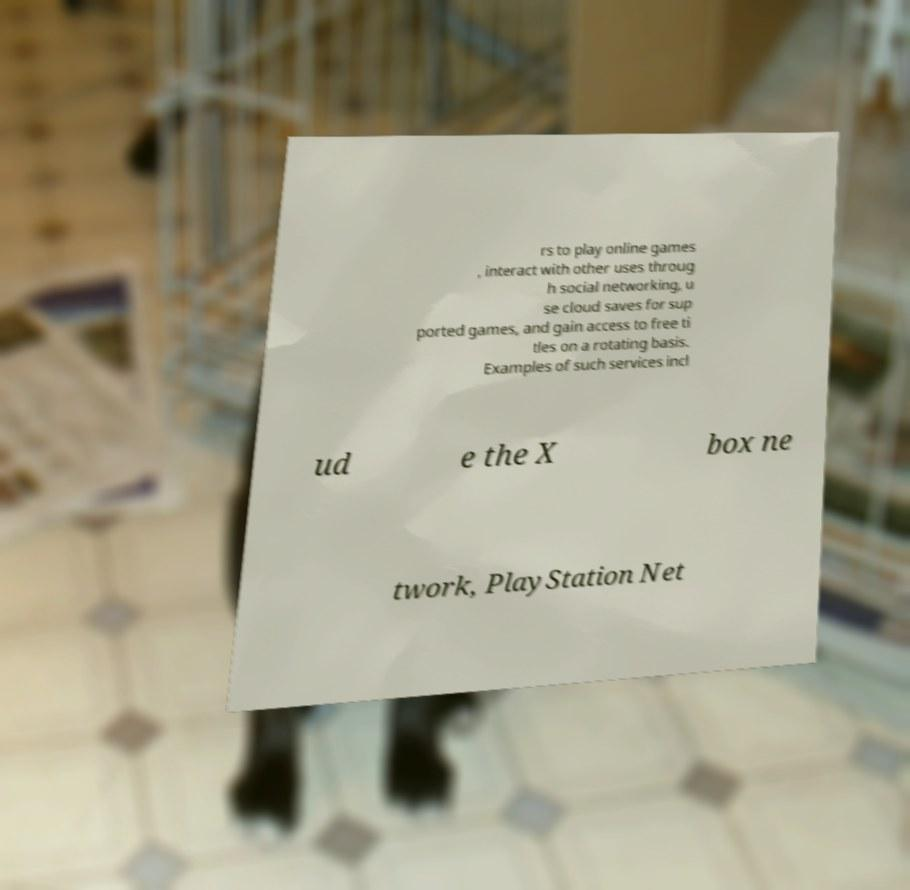For documentation purposes, I need the text within this image transcribed. Could you provide that? rs to play online games , interact with other uses throug h social networking, u se cloud saves for sup ported games, and gain access to free ti tles on a rotating basis. Examples of such services incl ud e the X box ne twork, PlayStation Net 